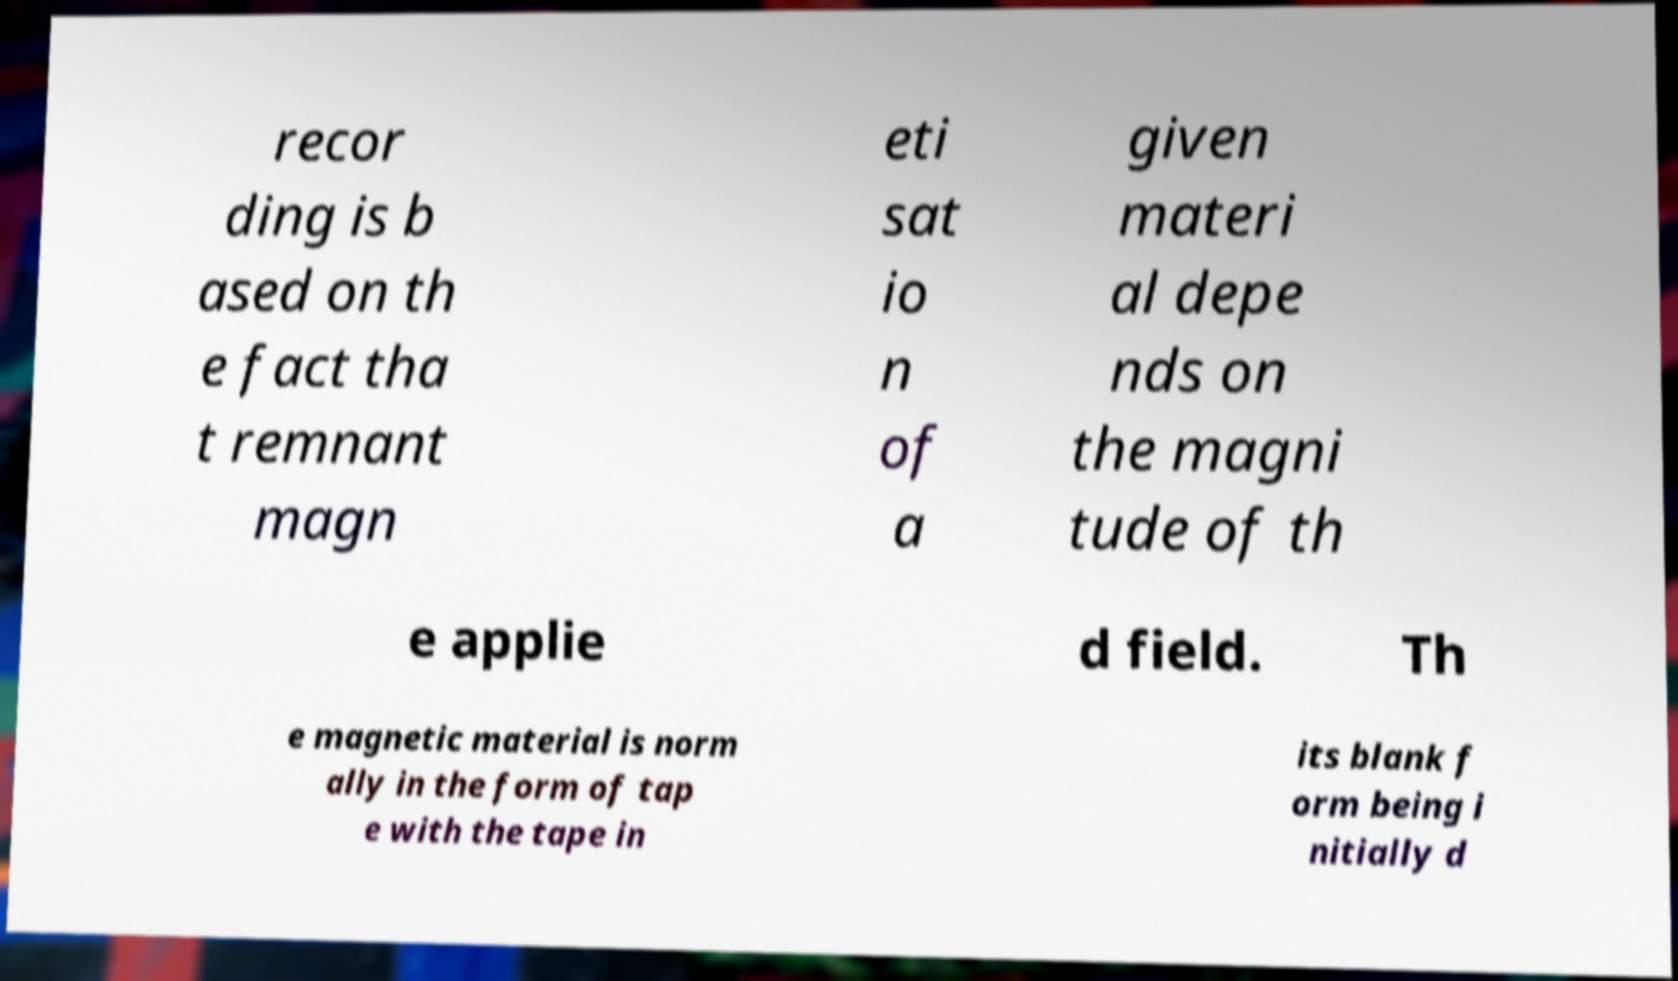There's text embedded in this image that I need extracted. Can you transcribe it verbatim? recor ding is b ased on th e fact tha t remnant magn eti sat io n of a given materi al depe nds on the magni tude of th e applie d field. Th e magnetic material is norm ally in the form of tap e with the tape in its blank f orm being i nitially d 